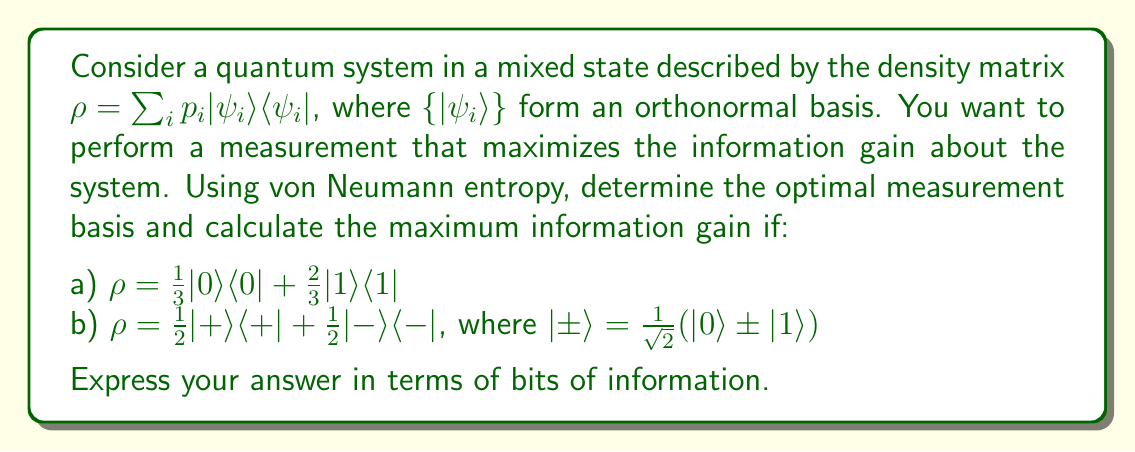Give your solution to this math problem. To solve this problem, we'll use the concept of von Neumann entropy and its relation to optimal quantum measurements. The steps are as follows:

1) The von Neumann entropy of a quantum state $\rho$ is given by:
   $$S(\rho) = -\text{Tr}(\rho \log_2 \rho) = -\sum_i \lambda_i \log_2 \lambda_i$$
   where $\lambda_i$ are the eigenvalues of $\rho$.

2) The optimal measurement basis is the eigenbasis of $\rho$, as this maximizes the information gain.

3) The maximum information gain is equal to the von Neumann entropy of the initial state.

For case a):
1) The density matrix is already in its eigenbasis: $\{|0\rangle, |1\rangle\}$
2) The eigenvalues are $\lambda_1 = \frac{1}{3}$ and $\lambda_2 = \frac{2}{3}$
3) The von Neumann entropy is:
   $$S(\rho) = -(\frac{1}{3} \log_2 \frac{1}{3} + \frac{2}{3} \log_2 \frac{2}{3}) \approx 0.9183 \text{ bits}$$

For case b):
1) First, we need to express $\rho$ in the computational basis:
   $$\rho = \frac{1}{2}(|0\rangle + |1\rangle)(\langle0| + \langle1|) + \frac{1}{2}(|0\rangle - |1\rangle)(\langle0| - \langle1|)$$
   $$= \frac{1}{2}(|0\rangle\langle0| + |0\rangle\langle1| + |1\rangle\langle0| + |1\rangle\langle1|) + \frac{1}{2}(|0\rangle\langle0| - |0\rangle\langle1| - |1\rangle\langle0| + |1\rangle\langle1|)$$
   $$= |0\rangle\langle0| + |1\rangle\langle1| = I$$

2) The eigenvalues of the identity matrix are both 1.
3) The von Neumann entropy is:
   $$S(\rho) = -(1 \log_2 1 + 1 \log_2 1) = 0 \text{ bits}$$

The optimal measurement basis for case b) is any orthonormal basis, as all bases are eigenbases of the identity matrix.
Answer: a) Optimal measurement basis: $\{|0\rangle, |1\rangle\}$
   Maximum information gain: $0.9183$ bits

b) Optimal measurement basis: Any orthonormal basis
   Maximum information gain: $0$ bits 